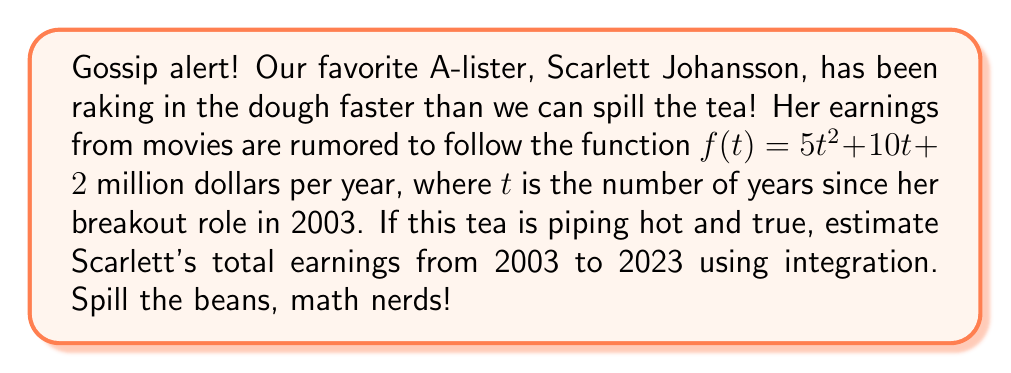Help me with this question. Alright, let's break this down like we're dissecting the juiciest celebrity scandal:

1) We need to integrate the earnings function over the time period from 2003 to 2023. This is a 20-year span, so our integral will be from $t=0$ to $t=20$.

2) The function to integrate is $f(t) = 5t^2 + 10t + 2$ million dollars per year.

3) We'll use the definite integral:

   $$\int_0^{20} (5t^2 + 10t + 2) dt$$

4) Let's integrate term by term:
   
   $$\int_0^{20} 5t^2 dt + \int_0^{20} 10t dt + \int_0^{20} 2 dt$$

5) Applying the power rule and evaluating:

   $$\left[\frac{5t^3}{3}\right]_0^{20} + \left[5t^2\right]_0^{20} + \left[2t\right]_0^{20}$$

6) Plugging in the limits:

   $$\left(\frac{5(20^3)}{3} - 0\right) + (5(20^2) - 0) + (2(20) - 0)$$

7) Simplifying:

   $$\frac{5(8000)}{3} + 2000 + 40$$

   $$\approx 13333.33 + 2000 + 40$$

   $$\approx 15373.33$$

Therefore, Scarlett's estimated total earnings over the 20-year period are approximately $15,373.33 million, or $15.37 billion.
Answer: $15.37 billion 